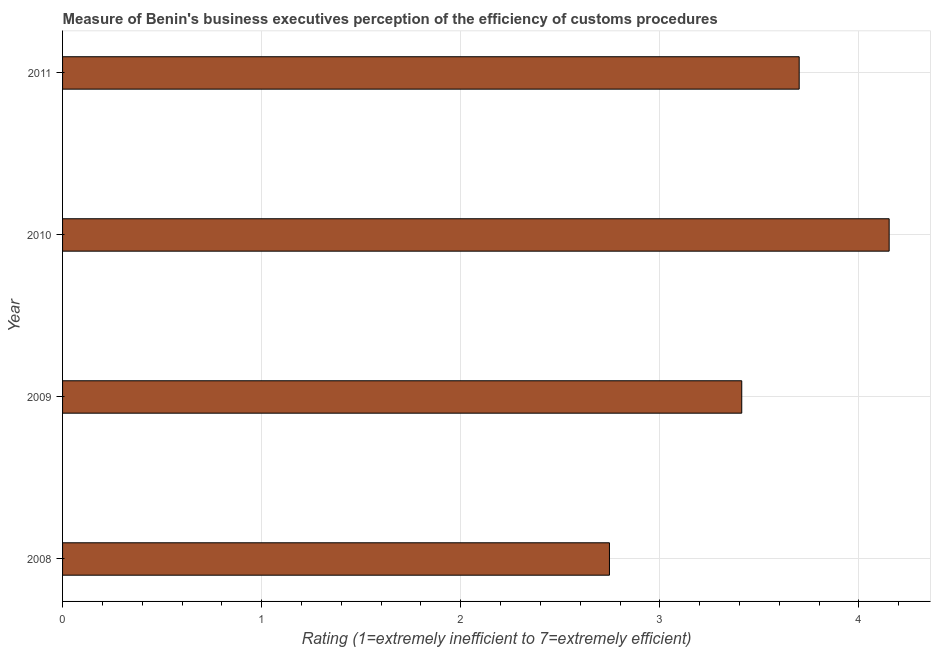What is the title of the graph?
Make the answer very short. Measure of Benin's business executives perception of the efficiency of customs procedures. What is the label or title of the X-axis?
Your answer should be compact. Rating (1=extremely inefficient to 7=extremely efficient). What is the rating measuring burden of customs procedure in 2010?
Your answer should be compact. 4.15. Across all years, what is the maximum rating measuring burden of customs procedure?
Give a very brief answer. 4.15. Across all years, what is the minimum rating measuring burden of customs procedure?
Your answer should be very brief. 2.75. What is the sum of the rating measuring burden of customs procedure?
Ensure brevity in your answer.  14.01. What is the difference between the rating measuring burden of customs procedure in 2009 and 2011?
Ensure brevity in your answer.  -0.29. What is the average rating measuring burden of customs procedure per year?
Provide a succinct answer. 3.5. What is the median rating measuring burden of customs procedure?
Your answer should be very brief. 3.56. In how many years, is the rating measuring burden of customs procedure greater than 1.8 ?
Offer a very short reply. 4. Do a majority of the years between 2008 and 2009 (inclusive) have rating measuring burden of customs procedure greater than 2.2 ?
Provide a short and direct response. Yes. What is the ratio of the rating measuring burden of customs procedure in 2008 to that in 2011?
Your answer should be compact. 0.74. Is the rating measuring burden of customs procedure in 2008 less than that in 2011?
Offer a very short reply. Yes. Is the difference between the rating measuring burden of customs procedure in 2008 and 2010 greater than the difference between any two years?
Offer a terse response. Yes. What is the difference between the highest and the second highest rating measuring burden of customs procedure?
Provide a succinct answer. 0.45. Is the sum of the rating measuring burden of customs procedure in 2009 and 2010 greater than the maximum rating measuring burden of customs procedure across all years?
Keep it short and to the point. Yes. What is the difference between the highest and the lowest rating measuring burden of customs procedure?
Offer a terse response. 1.4. How many bars are there?
Keep it short and to the point. 4. Are all the bars in the graph horizontal?
Your answer should be compact. Yes. What is the difference between two consecutive major ticks on the X-axis?
Give a very brief answer. 1. What is the Rating (1=extremely inefficient to 7=extremely efficient) of 2008?
Give a very brief answer. 2.75. What is the Rating (1=extremely inefficient to 7=extremely efficient) in 2009?
Your answer should be very brief. 3.41. What is the Rating (1=extremely inefficient to 7=extremely efficient) of 2010?
Keep it short and to the point. 4.15. What is the difference between the Rating (1=extremely inefficient to 7=extremely efficient) in 2008 and 2009?
Your answer should be very brief. -0.66. What is the difference between the Rating (1=extremely inefficient to 7=extremely efficient) in 2008 and 2010?
Give a very brief answer. -1.4. What is the difference between the Rating (1=extremely inefficient to 7=extremely efficient) in 2008 and 2011?
Offer a very short reply. -0.95. What is the difference between the Rating (1=extremely inefficient to 7=extremely efficient) in 2009 and 2010?
Your response must be concise. -0.74. What is the difference between the Rating (1=extremely inefficient to 7=extremely efficient) in 2009 and 2011?
Your response must be concise. -0.29. What is the difference between the Rating (1=extremely inefficient to 7=extremely efficient) in 2010 and 2011?
Your answer should be compact. 0.45. What is the ratio of the Rating (1=extremely inefficient to 7=extremely efficient) in 2008 to that in 2009?
Offer a very short reply. 0.81. What is the ratio of the Rating (1=extremely inefficient to 7=extremely efficient) in 2008 to that in 2010?
Your answer should be compact. 0.66. What is the ratio of the Rating (1=extremely inefficient to 7=extremely efficient) in 2008 to that in 2011?
Give a very brief answer. 0.74. What is the ratio of the Rating (1=extremely inefficient to 7=extremely efficient) in 2009 to that in 2010?
Your answer should be compact. 0.82. What is the ratio of the Rating (1=extremely inefficient to 7=extremely efficient) in 2009 to that in 2011?
Your response must be concise. 0.92. What is the ratio of the Rating (1=extremely inefficient to 7=extremely efficient) in 2010 to that in 2011?
Your answer should be very brief. 1.12. 